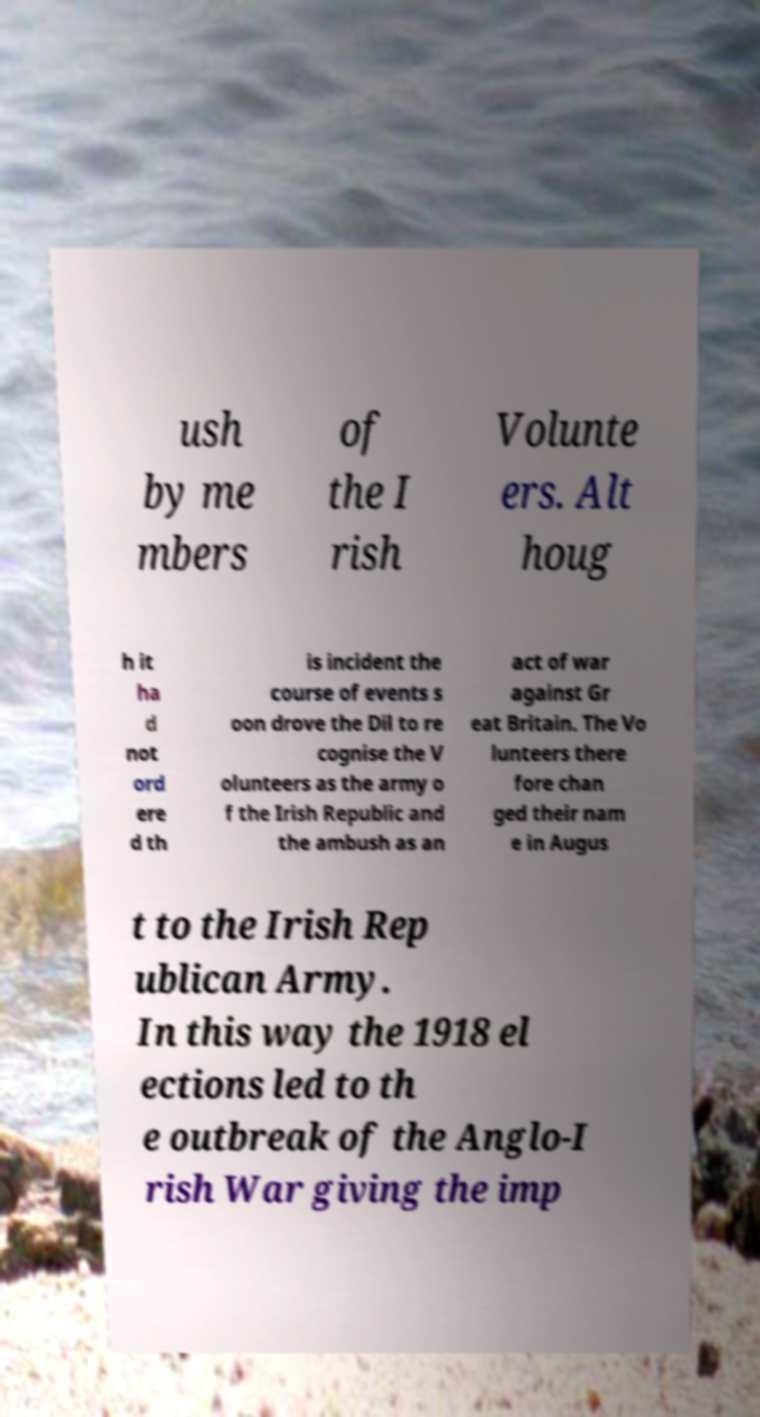What messages or text are displayed in this image? I need them in a readable, typed format. ush by me mbers of the I rish Volunte ers. Alt houg h it ha d not ord ere d th is incident the course of events s oon drove the Dil to re cognise the V olunteers as the army o f the Irish Republic and the ambush as an act of war against Gr eat Britain. The Vo lunteers there fore chan ged their nam e in Augus t to the Irish Rep ublican Army. In this way the 1918 el ections led to th e outbreak of the Anglo-I rish War giving the imp 